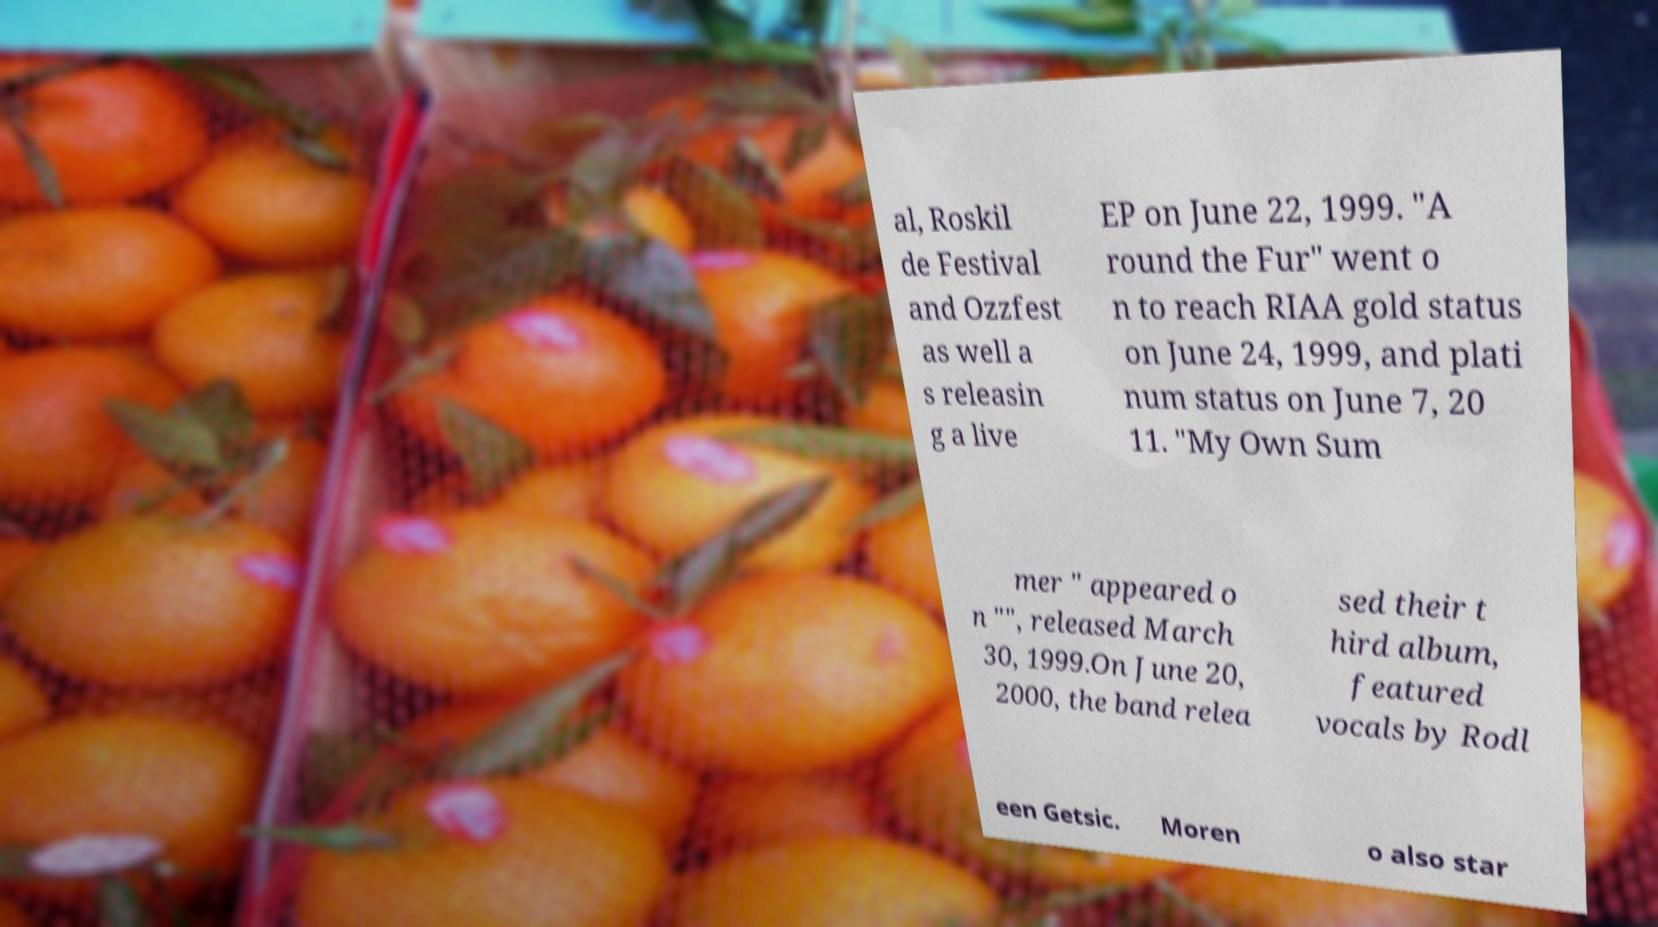Could you assist in decoding the text presented in this image and type it out clearly? al, Roskil de Festival and Ozzfest as well a s releasin g a live EP on June 22, 1999. "A round the Fur" went o n to reach RIAA gold status on June 24, 1999, and plati num status on June 7, 20 11. "My Own Sum mer " appeared o n "", released March 30, 1999.On June 20, 2000, the band relea sed their t hird album, featured vocals by Rodl een Getsic. Moren o also star 